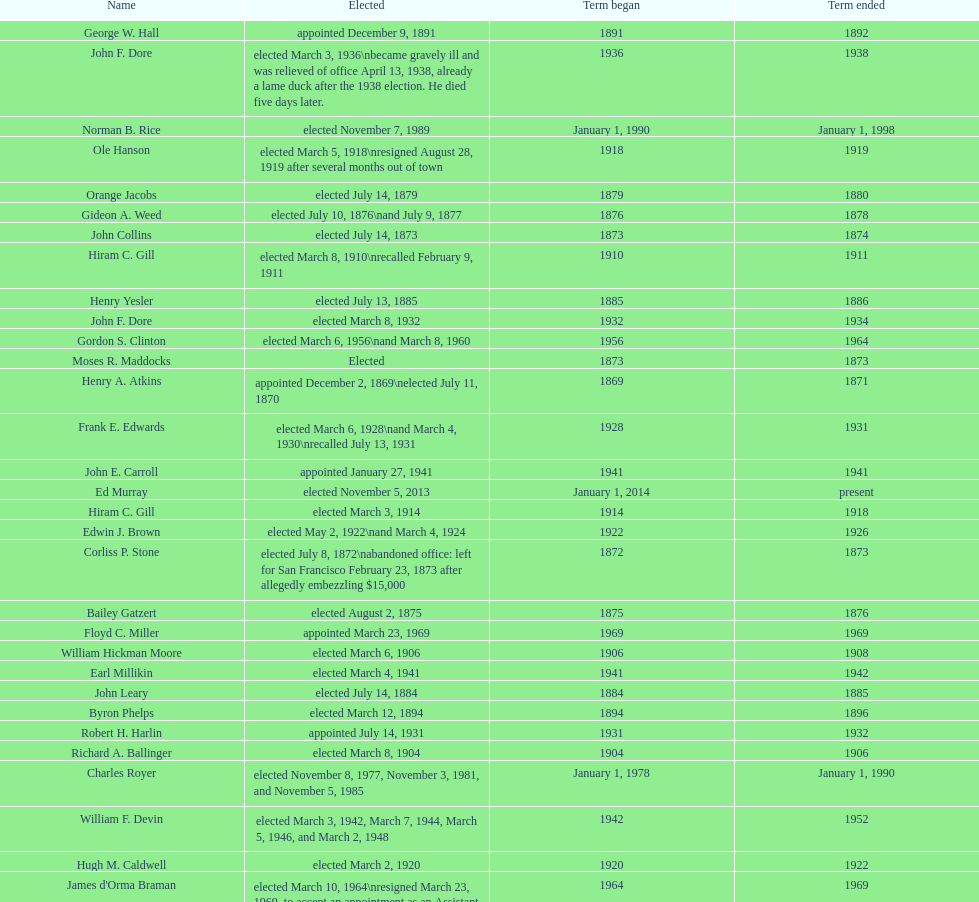Who was the mayor before jordan? Henry A. Atkins. 